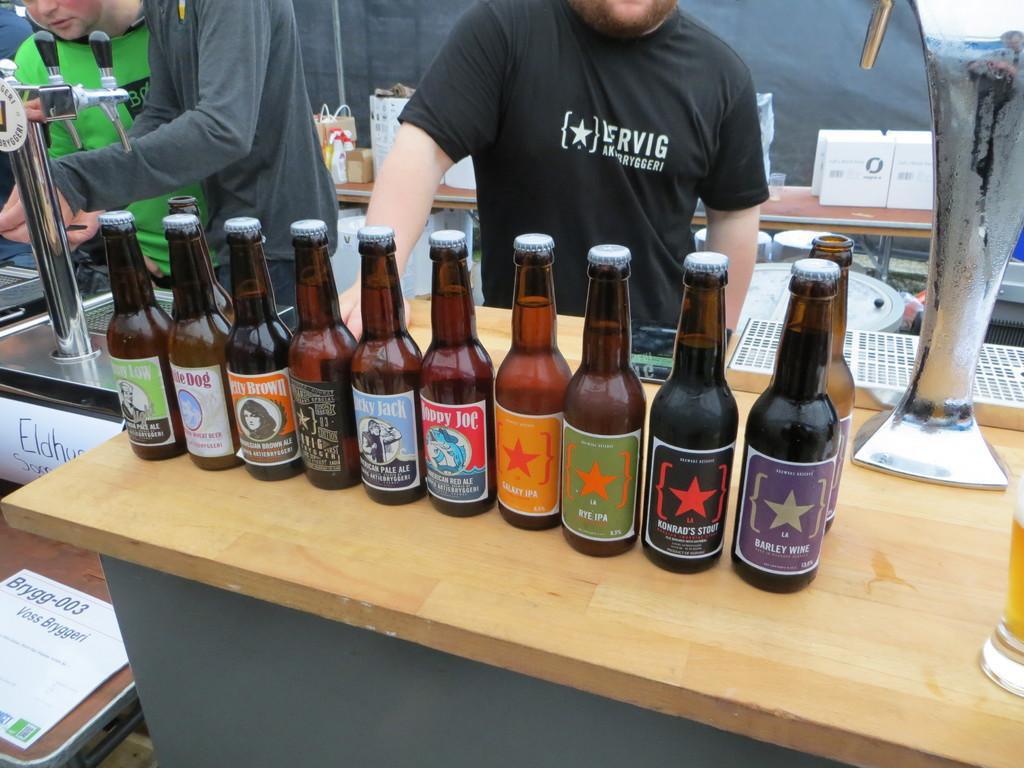Can you describe this image briefly? In this image I can see number of bottles on this table. In the background I can see few people are standing. 